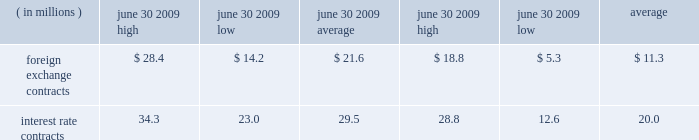In asset positions , which totaled $ 41.2 million at june 30 , 2009 .
To manage this risk , we have established strict counterparty credit guidelines that are continually monitored and reported to management .
Accordingly , management believes risk of loss under these hedging contracts is remote .
Certain of our derivative fi nancial instruments contain credit-risk-related contingent features .
As of june 30 , 2009 , we were in compliance with such features and there were no derivative financial instruments with credit-risk-related contingent features that were in a net liability position .
The est{e lauder companies inc .
111 market risk we use a value-at-risk model to assess the market risk of our derivative fi nancial instruments .
Value-at-risk rep resents the potential losses for an instrument or portfolio from adverse changes in market factors for a specifi ed time period and confi dence level .
We estimate value- at-risk across all of our derivative fi nancial instruments using a model with historical volatilities and correlations calculated over the past 250-day period .
The high , low and average measured value-at-risk for the twelve months ended june 30 , 2009 and 2008 related to our foreign exchange and interest rate contracts are as follows: .
The change in the value-at-risk measures from the prior year related to our foreign exchange contracts refl ected an increase in foreign exchange volatilities and a different portfolio mix .
The change in the value-at-risk measures from the prior year related to our interest rate contracts refl ected higher interest rate volatilities .
The model esti- mates were made assuming normal market conditions and a 95 percent confi dence level .
We used a statistical simulation model that valued our derivative fi nancial instruments against one thousand randomly generated market price paths .
Our calculated value-at-risk exposure represents an esti mate of reasonably possible net losses that would be recognized on our portfolio of derivative fi nancial instru- ments assuming hypothetical movements in future market rates and is not necessarily indicative of actual results , which may or may not occur .
It does not represent the maximum possible loss or any expected loss that may occur , since actual future gains and losses will differ from those estimated , based upon actual fl uctuations in market rates , operating exposures , and the timing thereof , and changes in our portfolio of derivative fi nancial instruments during the year .
We believe , however , that any such loss incurred would be offset by the effects of market rate movements on the respective underlying transactions for which the deriva- tive fi nancial instrument was intended .
Off-balance sheet arrangements we do not maintain any off-balance sheet arrangements , transactions , obligations or other relationships with unconsolidated entities that would be expected to have a material current or future effect upon our fi nancial condi- tion or results of operations .
Recently adopted accounting standards in may 2009 , the financial accounting standards board ( 201cfasb 201d ) issued statement of financial accounting standards ( 201csfas 201d ) no .
165 , 201csubsequent events 201d ( 201csfas no .
165 201d ) .
Sfas no .
165 requires the disclosure of the date through which an entity has evaluated subsequent events for potential recognition or disclosure in the fi nan- cial statements and whether that date represents the date the fi nancial statements were issued or were available to be issued .
This standard also provides clarifi cation about circumstances under which an entity should recognize events or transactions occurring after the balance sheet date in its fi nancial statements and the disclosures that an entity should make about events or transactions that occurred after the balance sheet date .
This standard is effective for interim and annual periods beginning with our fi scal year ended june 30 , 2009 .
The adoption of this standard did not have a material impact on our consoli- dated fi nancial statements .
In march 2008 , the fasb issued sfas no .
161 , 201cdisclosures about derivative instruments and hedging activities 2014 an amendment of fasb statement no .
133 201d ( 201csfas no .
161 201d ) .
Sfas no .
161 requires companies to provide qualitative disclosures about their objectives and strategies for using derivative instruments , quantitative disclosures of the fair values of , and gains and losses on , these derivative instruments in a tabular format , as well as more information about liquidity by requiring disclosure of a derivative contract 2019s credit-risk-related contingent .
Considering the year 2008 , what is the variation between the high of foreign exchange contracts and the high of the interest rate contracts? 
Rationale: it is the difference between these values.\\n
Computations: (34.3 - 28.4)
Answer: 5.9. 